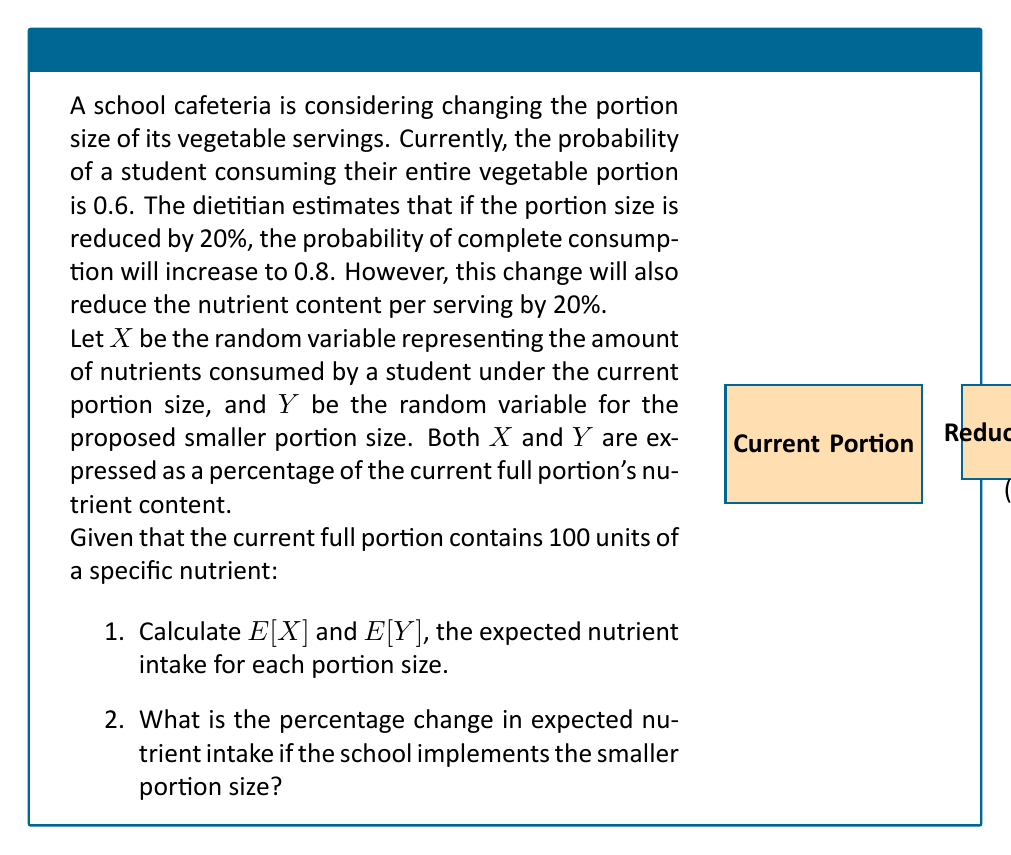Help me with this question. Let's approach this problem step-by-step:

1. Calculate E[X] (current portion):
   - If consumed (probability 0.6), X = 100% of nutrients
   - If not consumed (probability 0.4), X = 0% of nutrients
   $$E[X] = 0.6 \cdot 100\% + 0.4 \cdot 0\% = 60\%$$

2. Calculate E[Y] (reduced portion):
   - The new portion contains 80% of the original nutrients
   - If consumed (probability 0.8), Y = 80% of original nutrients
   - If not consumed (probability 0.2), Y = 0% of original nutrients
   $$E[Y] = 0.8 \cdot 80\% + 0.2 \cdot 0\% = 64\%$$

3. Calculate the percentage change:
   $$\text{Percentage Change} = \frac{E[Y] - E[X]}{E[X]} \cdot 100\%$$
   $$= \frac{64\% - 60\%}{60\%} \cdot 100\% = \frac{4\%}{60\%} \cdot 100\% = 6.67\%$$

Therefore, implementing the smaller portion size is expected to increase the average nutrient intake by approximately 6.67%.
Answer: 6.67% increase 